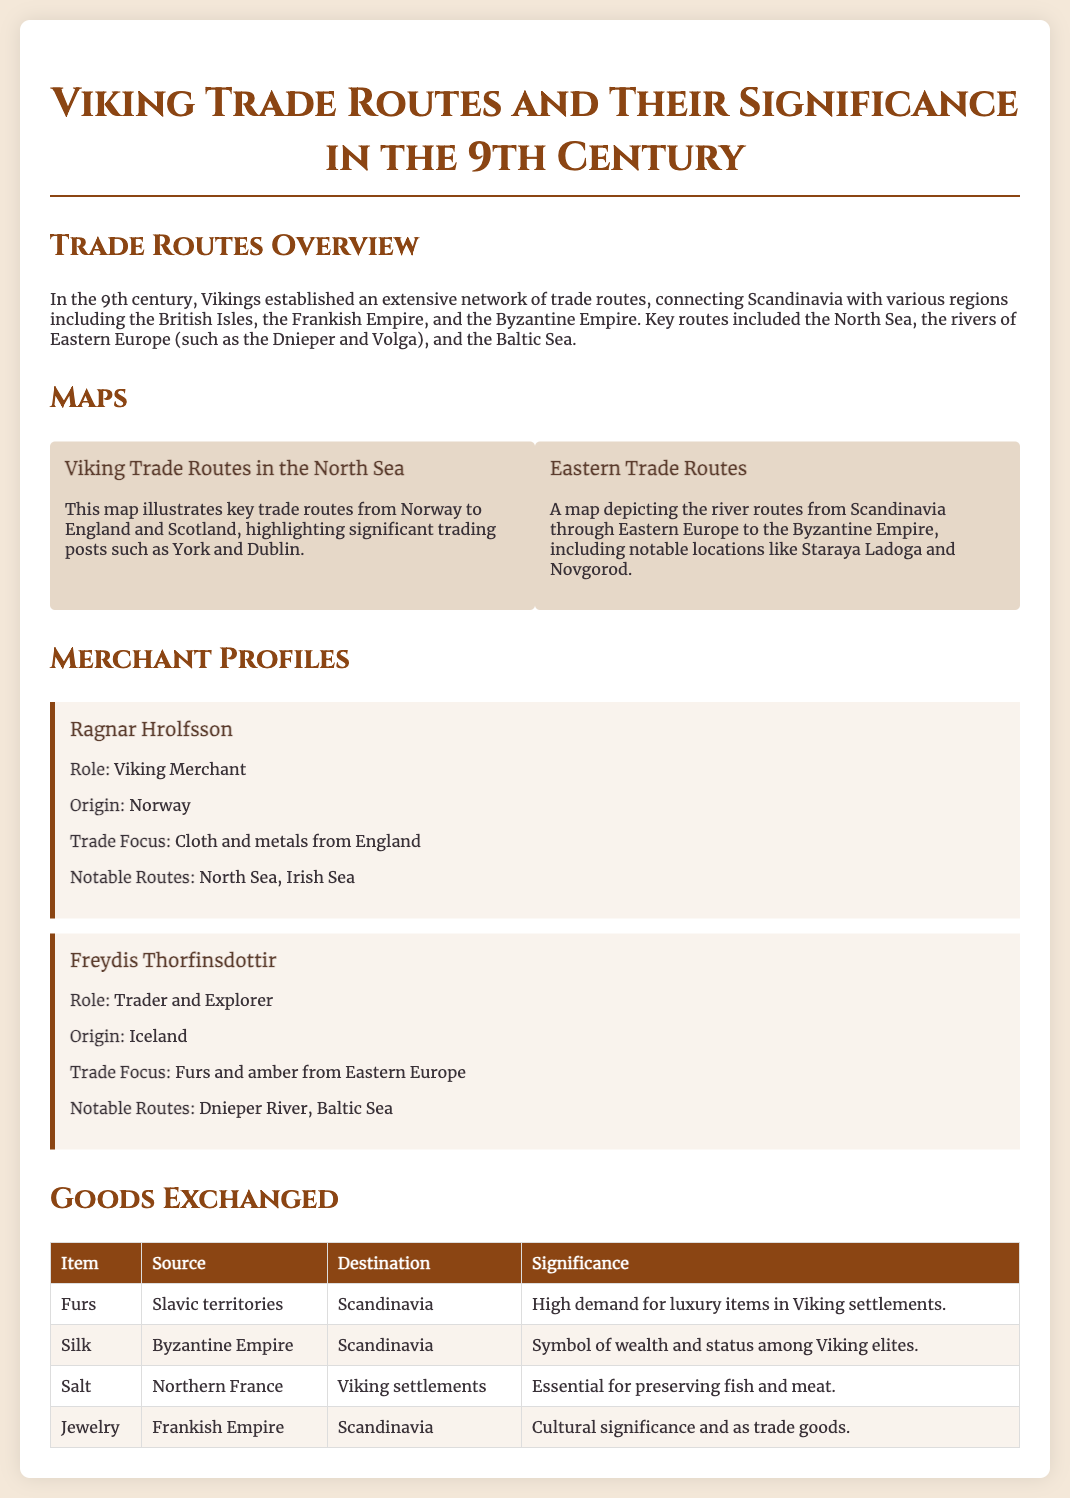What were the key regions connected by Viking trade routes in the 9th century? The document states that Vikings connected Scandinavia with the British Isles, the Frankish Empire, and the Byzantine Empire.
Answer: British Isles, Frankish Empire, Byzantine Empire Who was a notable Viking merchant from Norway? The document mentions Ragnar Hrolfsson as a Viking merchant from Norway.
Answer: Ragnar Hrolfsson What goods did Freydis Thorfinsdottir trade? According to the merchant profile, Freydis traded furs and amber from Eastern Europe.
Answer: Furs and amber What was a primary source of silk for the Vikings? The document specifies that silk originated from the Byzantine Empire.
Answer: Byzantine Empire What was the significance of jewelry in Viking trade? The goods exchanged table notes that jewelry had cultural significance and served as trade goods.
Answer: Cultural significance and trade goods What are the two notable routes mentioned in the merchant profiles? Ragnar Hrolfsson's notable routes were the North Sea and Irish Sea; Freydis Thorfinsdottir's were the Dnieper River and Baltic Sea.
Answer: North Sea, Irish Sea; Dnieper River, Baltic Sea Which item was essential for preserving fish and meat? The goods exchanged table indicates that salt was essential for preserving fish and meat.
Answer: Salt What were Viking settlements in high demand for? The document notes that there was high demand for luxury items, specifically furs.
Answer: Furs 